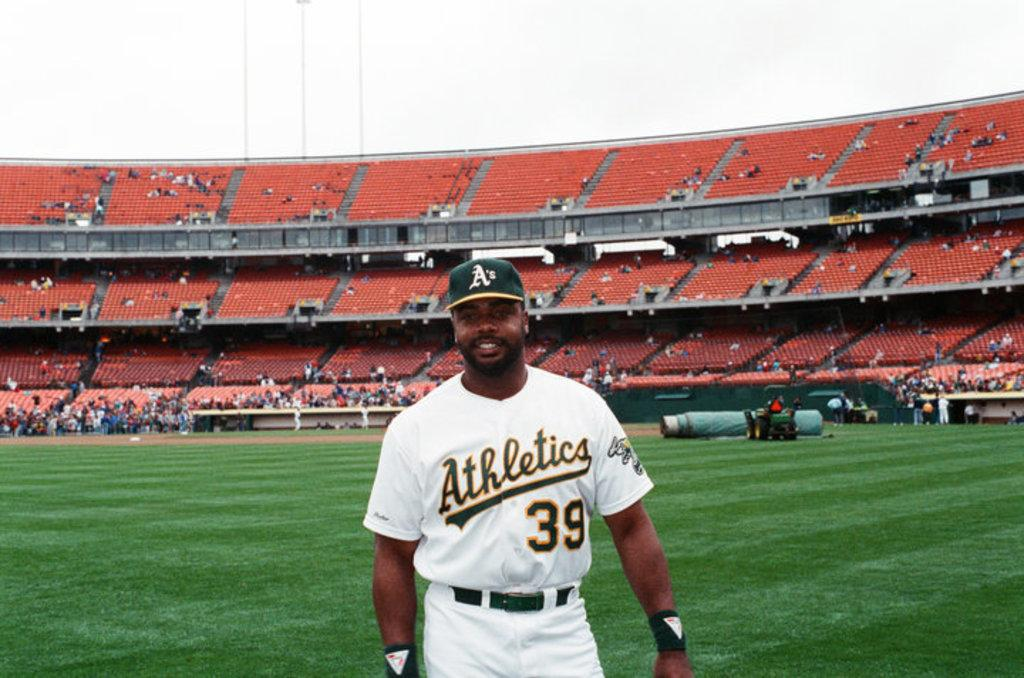<image>
Provide a brief description of the given image. Man wearing a jersey which says Athletics on it. 